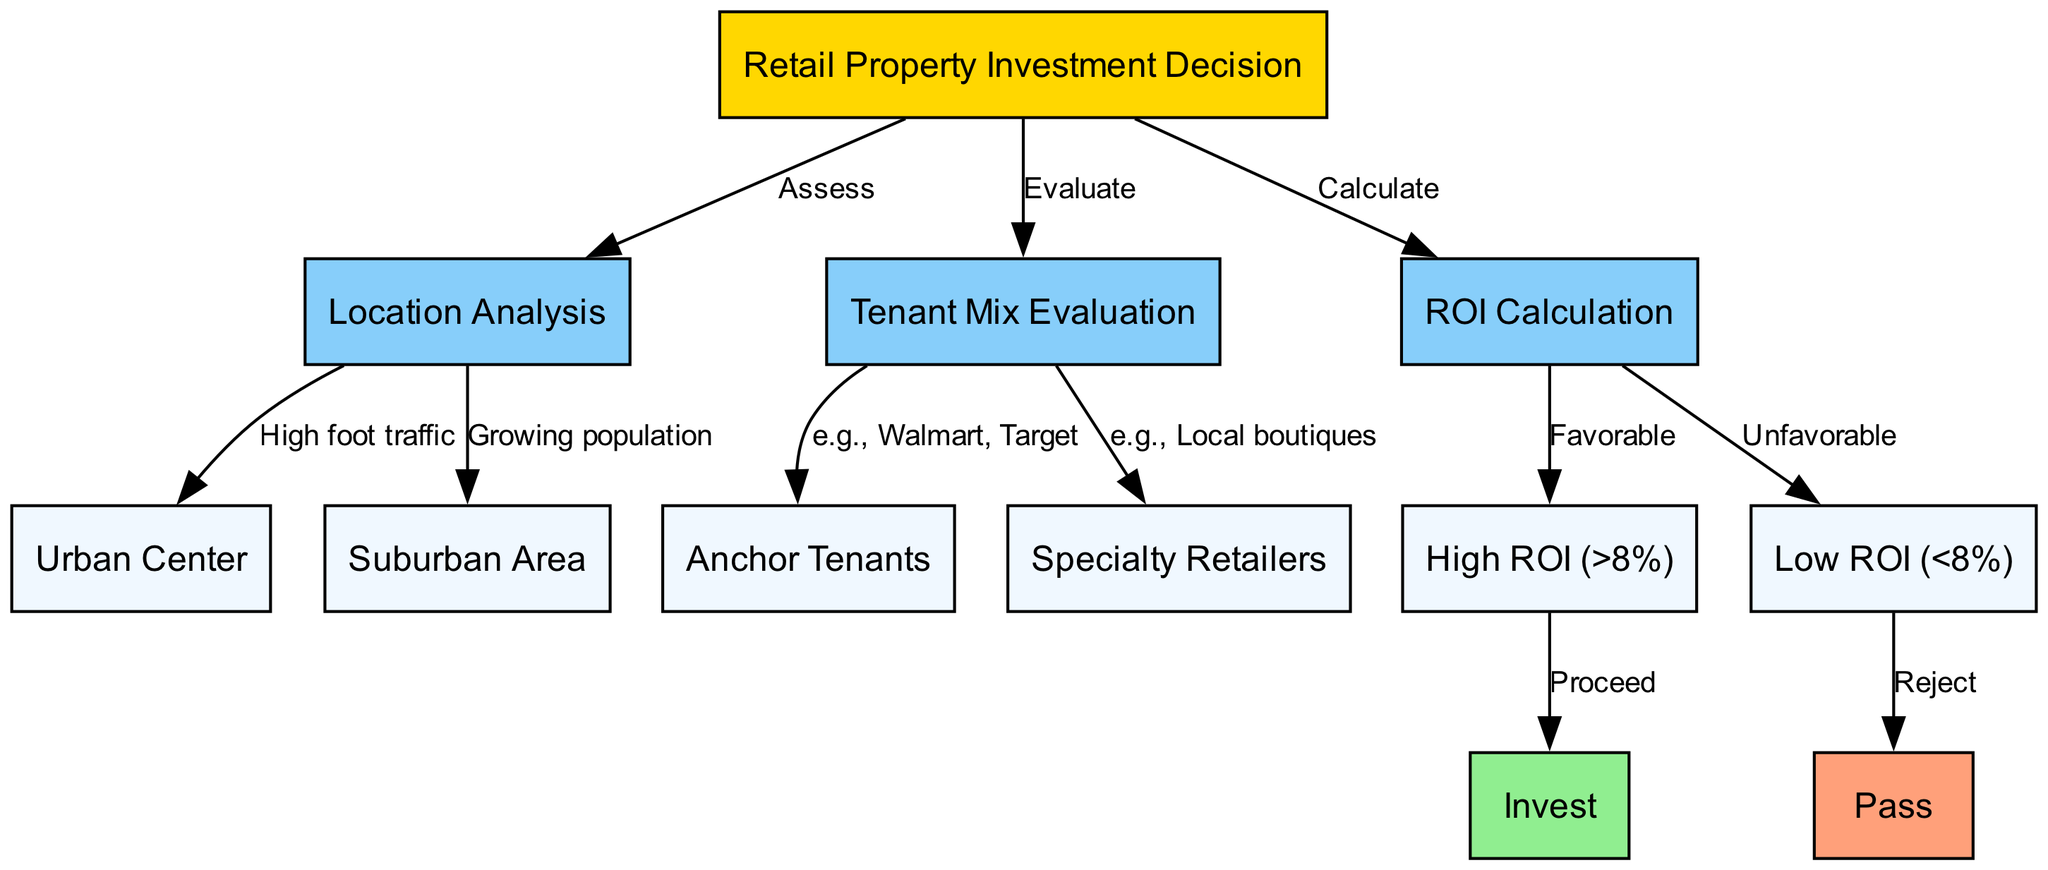What is the starting point of the investment decision? The diagram starts at the "Retail Property Investment Decision" node, which indicates the overall goal of the process.
Answer: Retail Property Investment Decision How many types of location analyses are present in the diagram? The diagram shows two specific types of location analyses: "Urban Center" and "Suburban Area," which derive from the "Location Analysis" node.
Answer: 2 Which node leads to "High ROI"? The "ROI Calculation" node leads to "High ROI," signifying a positive outcome in the calculation.
Answer: ROI Calculation What types of tenant mixes are evaluated in the diagram? The diagram evaluates "Anchor Tenants" and "Specialty Retailers," both stemming from the "Tenant Mix Evaluation" node.
Answer: Anchor Tenants, Specialty Retailers What action is taken if the ROI is low? If the ROI calculation results in "Low ROI," the action is to "Pass," indicating a decision not to invest.
Answer: Pass If the location is in an urban center, what type of tenant should you evaluate? If the location analysis identifies an "Urban Center," the focus for tenant evaluation should typically be on "Anchor Tenants."
Answer: Anchor Tenants What are the potential outcomes from high ROI calculations? A favorable outcome from high ROI calculations leads to the decision to "Invest," representing a successful investment opportunity.
Answer: Invest What is the relationship between high ROI and investment action? The relationship is direct: high ROI leads to the action of investing, demonstrating a beneficial investment rationale based on financial return.
Answer: Invest Which edges connect the nodes in the tenant mix evaluation? The edges connect "Tenant Mix Evaluation" to "Anchor Tenants" and "Specialty Retailers," representing different categories within tenant evaluation.
Answer: Anchor Tenants, Specialty Retailers 